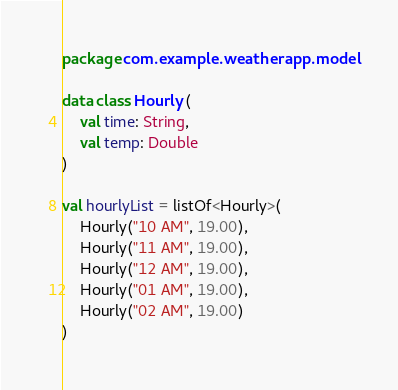Convert code to text. <code><loc_0><loc_0><loc_500><loc_500><_Kotlin_>package com.example.weatherapp.model

data class Hourly (
    val time: String,
    val temp: Double
)

val hourlyList = listOf<Hourly>(
    Hourly("10 AM", 19.00),
    Hourly("11 AM", 19.00),
    Hourly("12 AM", 19.00),
    Hourly("01 AM", 19.00),
    Hourly("02 AM", 19.00)
)</code> 